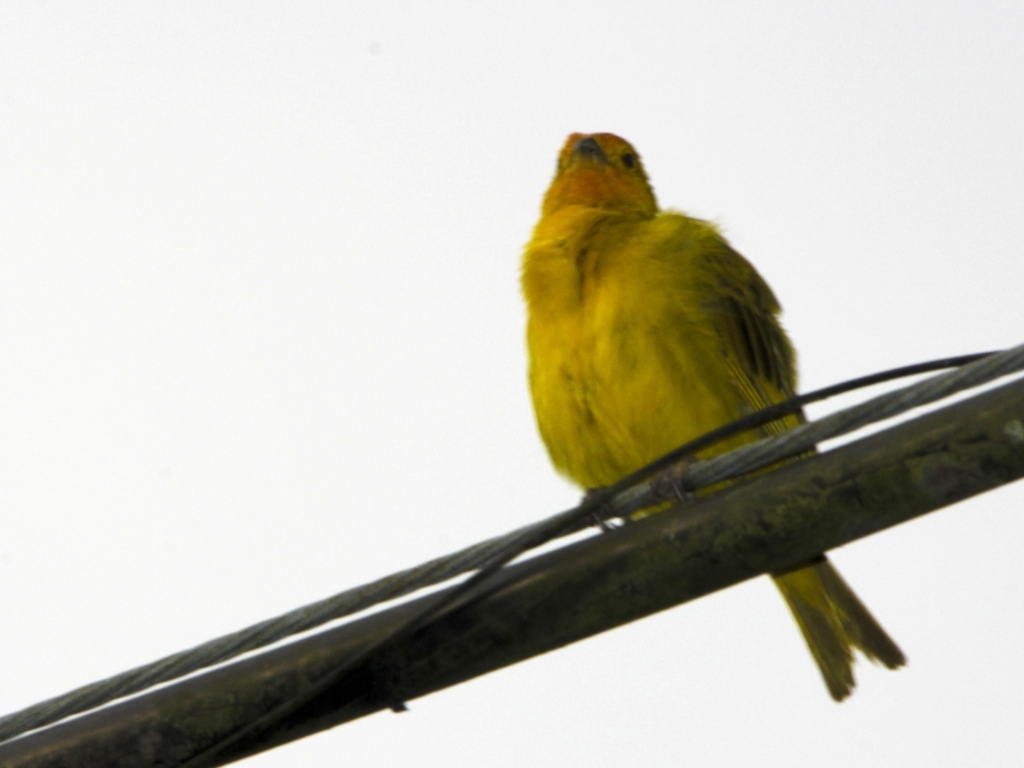Is the image visually appealing? While beauty is subjective, the composition and subject of the photograph—a bird perched on a wire—could exhibit visual appeal through its simplicity and focus on the bird. However, the overexposed background detracts from the overall aesthetic, which may lead some viewers to find it less appealing. 